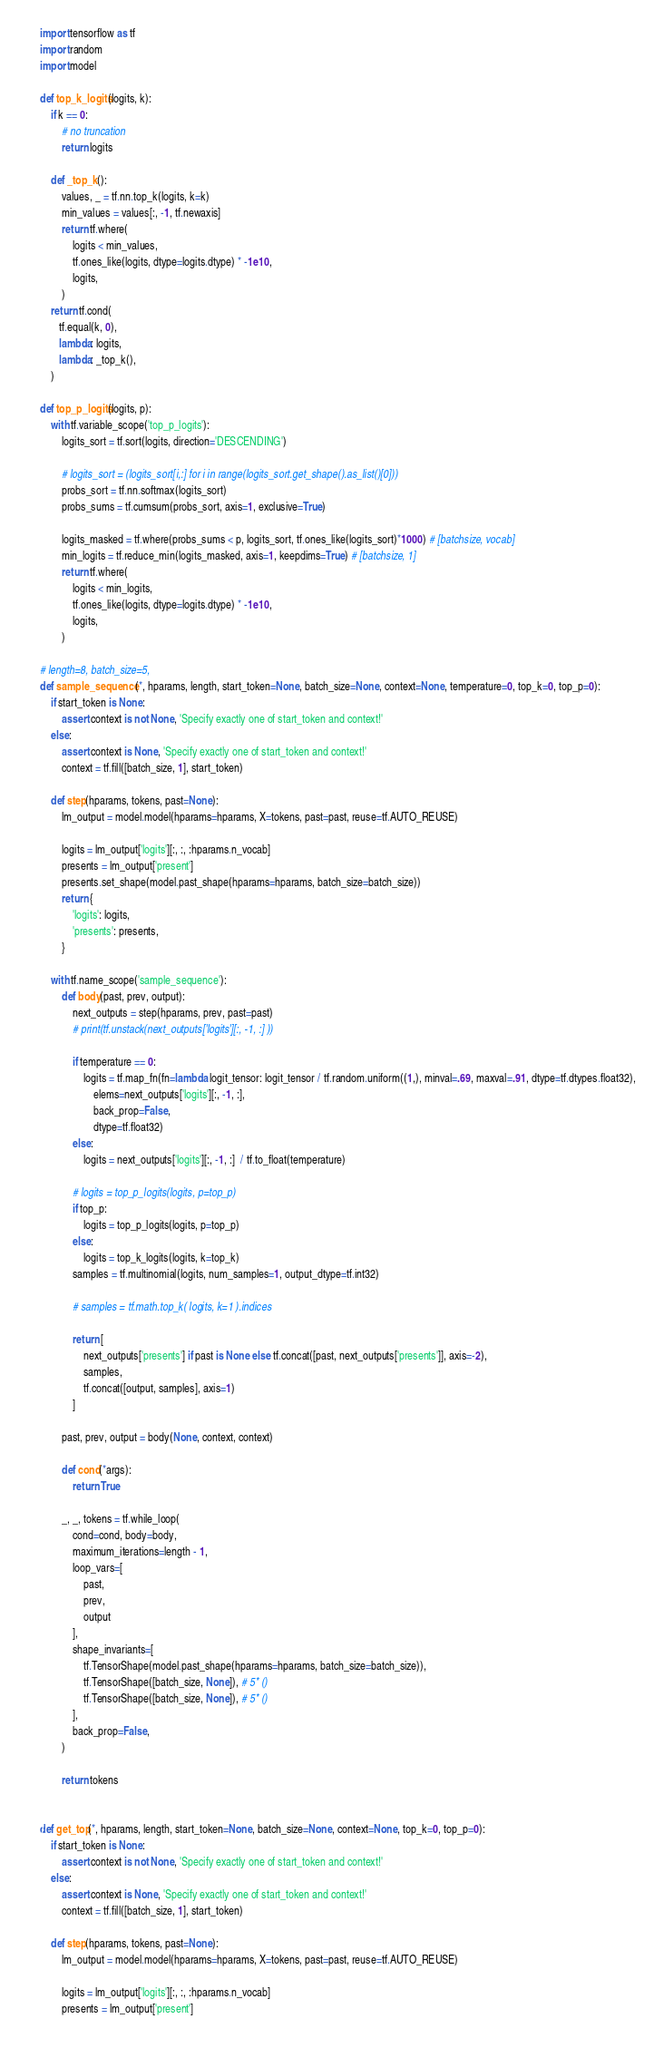<code> <loc_0><loc_0><loc_500><loc_500><_Python_>import tensorflow as tf
import random
import model

def top_k_logits(logits, k):
    if k == 0:
        # no truncation
        return logits

    def _top_k():
        values, _ = tf.nn.top_k(logits, k=k)
        min_values = values[:, -1, tf.newaxis]
        return tf.where(
            logits < min_values,
            tf.ones_like(logits, dtype=logits.dtype) * -1e10,
            logits,
        )
    return tf.cond(
       tf.equal(k, 0),
       lambda: logits,
       lambda: _top_k(),
    )

def top_p_logits(logits, p):
    with tf.variable_scope('top_p_logits'):
        logits_sort = tf.sort(logits, direction='DESCENDING')

        # logits_sort = (logits_sort[i,:] for i in range(logits_sort.get_shape().as_list()[0]))
        probs_sort = tf.nn.softmax(logits_sort)
        probs_sums = tf.cumsum(probs_sort, axis=1, exclusive=True)

        logits_masked = tf.where(probs_sums < p, logits_sort, tf.ones_like(logits_sort)*1000) # [batchsize, vocab]
        min_logits = tf.reduce_min(logits_masked, axis=1, keepdims=True) # [batchsize, 1]
        return tf.where(
            logits < min_logits,
            tf.ones_like(logits, dtype=logits.dtype) * -1e10,
            logits,
        )

# length=8, batch_size=5,
def sample_sequence(*, hparams, length, start_token=None, batch_size=None, context=None, temperature=0, top_k=0, top_p=0):
    if start_token is None:
        assert context is not None, 'Specify exactly one of start_token and context!'
    else:
        assert context is None, 'Specify exactly one of start_token and context!'
        context = tf.fill([batch_size, 1], start_token)

    def step(hparams, tokens, past=None):
        lm_output = model.model(hparams=hparams, X=tokens, past=past, reuse=tf.AUTO_REUSE)

        logits = lm_output['logits'][:, :, :hparams.n_vocab]
        presents = lm_output['present']
        presents.set_shape(model.past_shape(hparams=hparams, batch_size=batch_size))
        return {
            'logits': logits,
            'presents': presents,
        }

    with tf.name_scope('sample_sequence'):
        def body(past, prev, output):
            next_outputs = step(hparams, prev, past=past)
            # print(tf.unstack(next_outputs['logits'][:, -1, :] ))

            if temperature == 0:
                logits = tf.map_fn(fn=lambda logit_tensor: logit_tensor / tf.random.uniform((1,), minval=.69, maxval=.91, dtype=tf.dtypes.float32),
                    elems=next_outputs['logits'][:, -1, :],
                    back_prop=False,
                    dtype=tf.float32)
            else:
                logits = next_outputs['logits'][:, -1, :]  / tf.to_float(temperature)

            # logits = top_p_logits(logits, p=top_p)
            if top_p:
                logits = top_p_logits(logits, p=top_p)
            else:
                logits = top_k_logits(logits, k=top_k)
            samples = tf.multinomial(logits, num_samples=1, output_dtype=tf.int32)

            # samples = tf.math.top_k( logits, k=1 ).indices

            return [
                next_outputs['presents'] if past is None else tf.concat([past, next_outputs['presents']], axis=-2),
                samples,
                tf.concat([output, samples], axis=1)
            ]

        past, prev, output = body(None, context, context)

        def cond(*args):
            return True

        _, _, tokens = tf.while_loop(
            cond=cond, body=body,
            maximum_iterations=length - 1,
            loop_vars=[
                past,
                prev,
                output
            ],
            shape_invariants=[
                tf.TensorShape(model.past_shape(hparams=hparams, batch_size=batch_size)),
                tf.TensorShape([batch_size, None]), # 5* ()
                tf.TensorShape([batch_size, None]), # 5* ()
            ],
            back_prop=False,
        )

        return tokens


def get_top(*, hparams, length, start_token=None, batch_size=None, context=None, top_k=0, top_p=0):
    if start_token is None:
        assert context is not None, 'Specify exactly one of start_token and context!'
    else:
        assert context is None, 'Specify exactly one of start_token and context!'
        context = tf.fill([batch_size, 1], start_token)

    def step(hparams, tokens, past=None):
        lm_output = model.model(hparams=hparams, X=tokens, past=past, reuse=tf.AUTO_REUSE)

        logits = lm_output['logits'][:, :, :hparams.n_vocab]
        presents = lm_output['present']</code> 